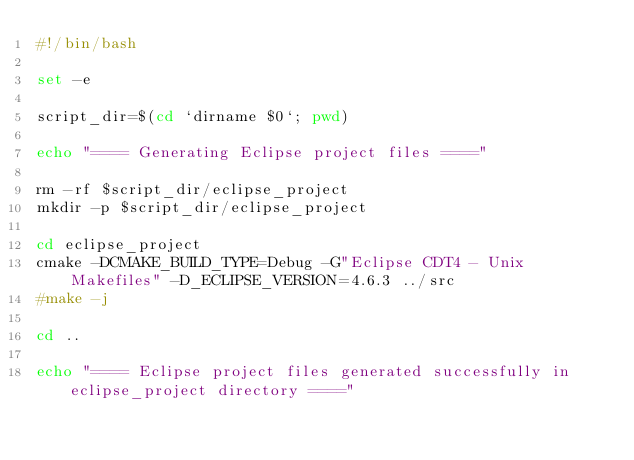Convert code to text. <code><loc_0><loc_0><loc_500><loc_500><_Bash_>#!/bin/bash

set -e

script_dir=$(cd `dirname $0`; pwd)

echo "==== Generating Eclipse project files ===="

rm -rf $script_dir/eclipse_project
mkdir -p $script_dir/eclipse_project

cd eclipse_project
cmake -DCMAKE_BUILD_TYPE=Debug -G"Eclipse CDT4 - Unix Makefiles" -D_ECLIPSE_VERSION=4.6.3 ../src
#make -j

cd ..

echo "==== Eclipse project files generated successfully in eclipse_project directory ===="
</code> 